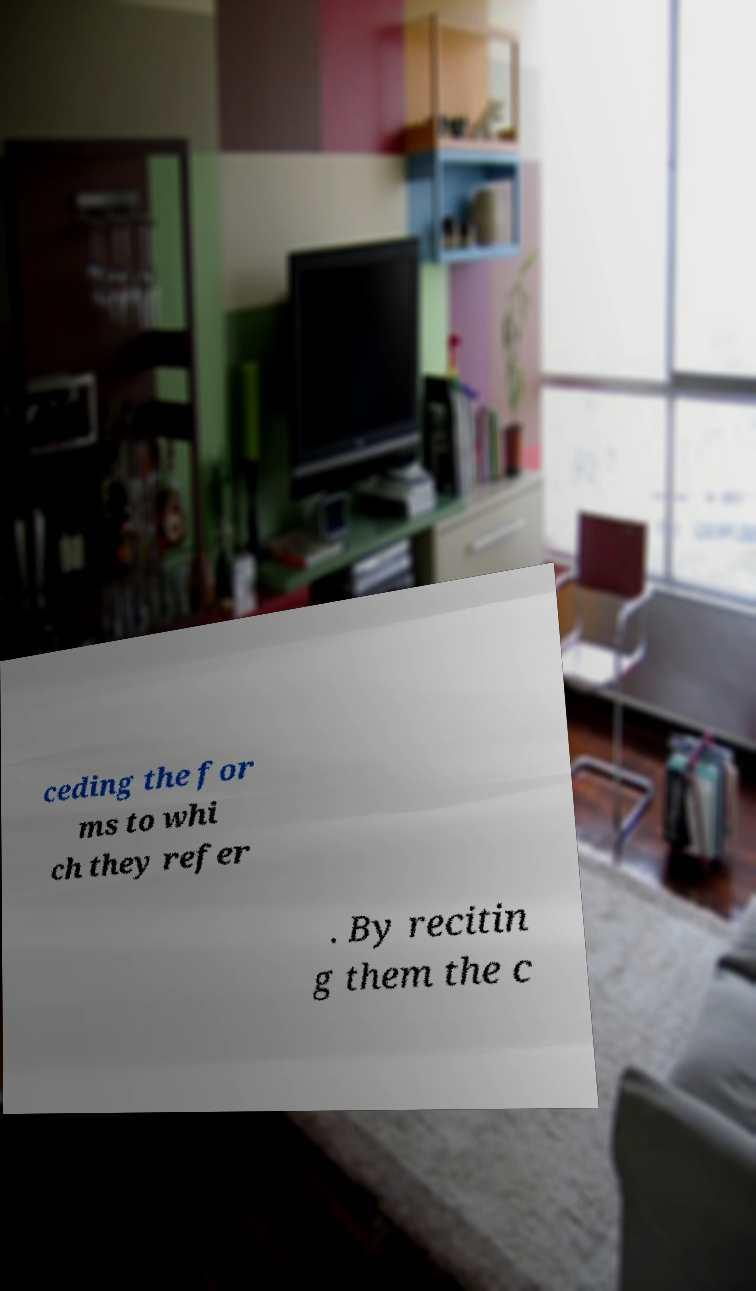Please identify and transcribe the text found in this image. ceding the for ms to whi ch they refer . By recitin g them the c 